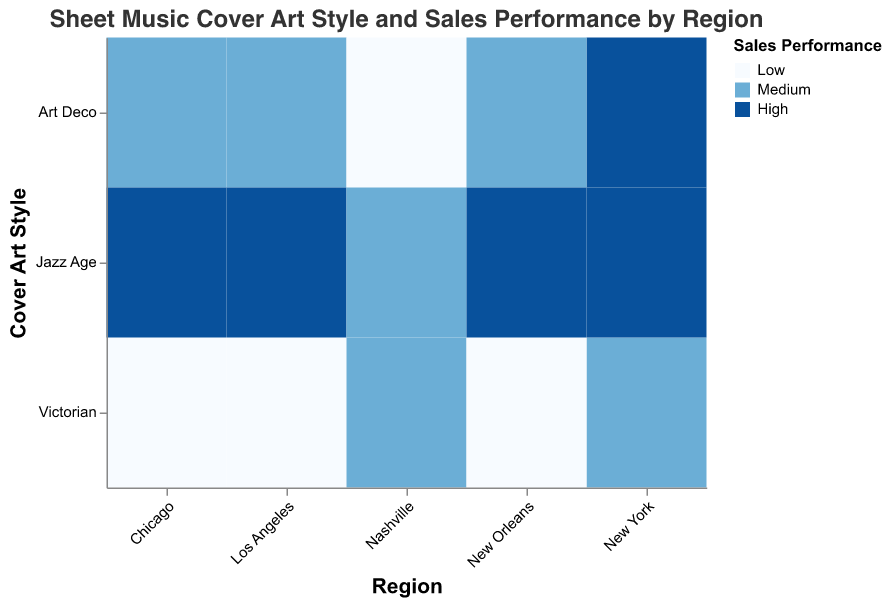Which region has the highest sales performance for Art Deco cover art? Observing the color pattern for Art Deco cover art across the regions, New York has the darkest shade of blue, indicating 'High' sales performance.
Answer: New York Which cover art style in Nashville had Medium sales performance? Referencing the y-axis for cover art styles in Nashville and identifying the corresponding color, the Medium shade of blue is associated with both Victorian and Jazz Age styles.
Answer: Victorian and Jazz Age What sales performance is associated with Victorian cover art in Chicago? Looking at the intersection of Chicago and Victorian styles, the color indicates a light shade of blue which corresponds to 'Low' sales performance.
Answer: Low Compare the sales performance of Jazz Age cover art between New York and Los Angeles. By comparing the colors at the intersections of New York and Los Angeles with Jazz Age, New York shows a dark blue (High) while Los Angeles also shows a dark blue (High).
Answer: Both High How many regions have Medium sales performance for Art Deco cover art? Count the regions where the Art Deco cover intersects with the medium shade of blue: Los Angeles, Chicago, and New Orleans.
Answer: Three Identify the cover art styles with High sales performance in New York. Checking the colors for New York across all cover art styles, the darkest blue (High) appears for Art Deco and Jazz Age.
Answer: Art Deco and Jazz Age Which combination of region and cover art style has the lowest sales performance? The colors indicating the lightest blue (Low) intersect at Los Angeles with Victorian style and Chicago with Victorian style as well.
Answer: Los Angeles and Chicago with Victorian Is there any region where all cover art styles have the same sales performance? By comparing the colors across each cover art style within individual regions, all regions show varying sales performances for different cover art styles.
Answer: No What is the combined number of times the 'High' sales performance appears for any cover art style across all regions? Count the number of dark blue (high) colors: New York (Art Deco, Jazz Age), Los Angeles (Jazz Age), Chicago (Jazz Age), New Orleans (Jazz Age); thus a total of five appearances.
Answer: Five 